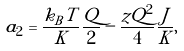Convert formula to latex. <formula><loc_0><loc_0><loc_500><loc_500>a _ { 2 } = \frac { k _ { B } T } { K } \frac { Q } { 2 } - \frac { z Q ^ { 2 } } { 4 } \frac { J } { K } ,</formula> 